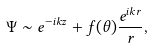Convert formula to latex. <formula><loc_0><loc_0><loc_500><loc_500>\Psi \sim e ^ { - i k z } + f ( \theta ) \frac { e ^ { i k r } } { r } ,</formula> 